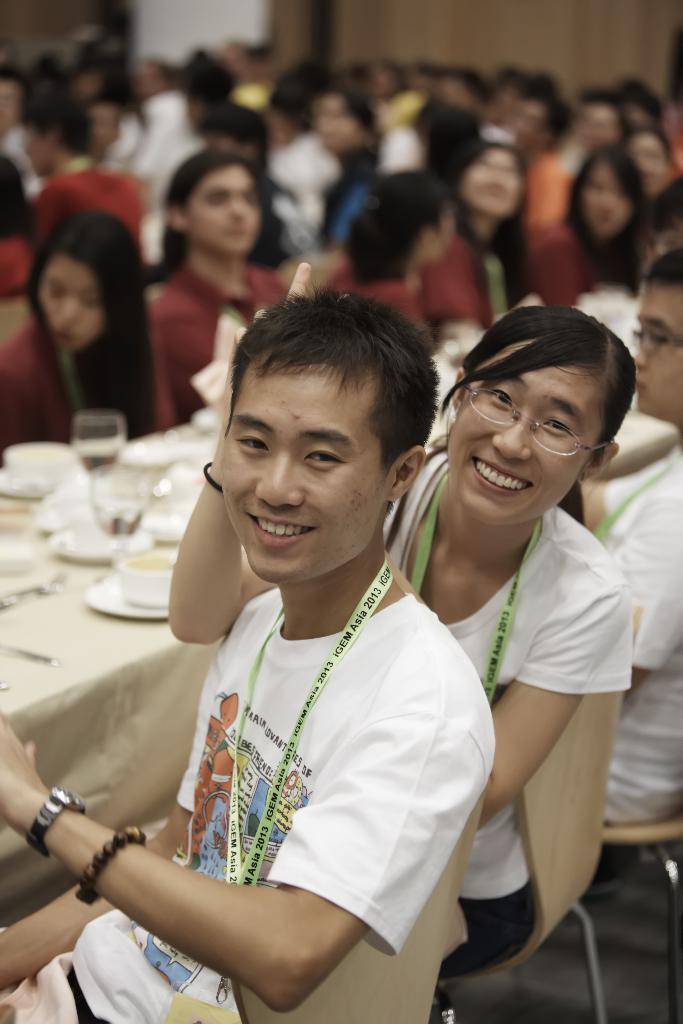How would you summarize this image in a sentence or two? There are persons with different color T-shirts, sitting on chairs in front of the tables, on which there are glasses, cups and other objects. Some of these persons are smiling. And the background is blurred. 